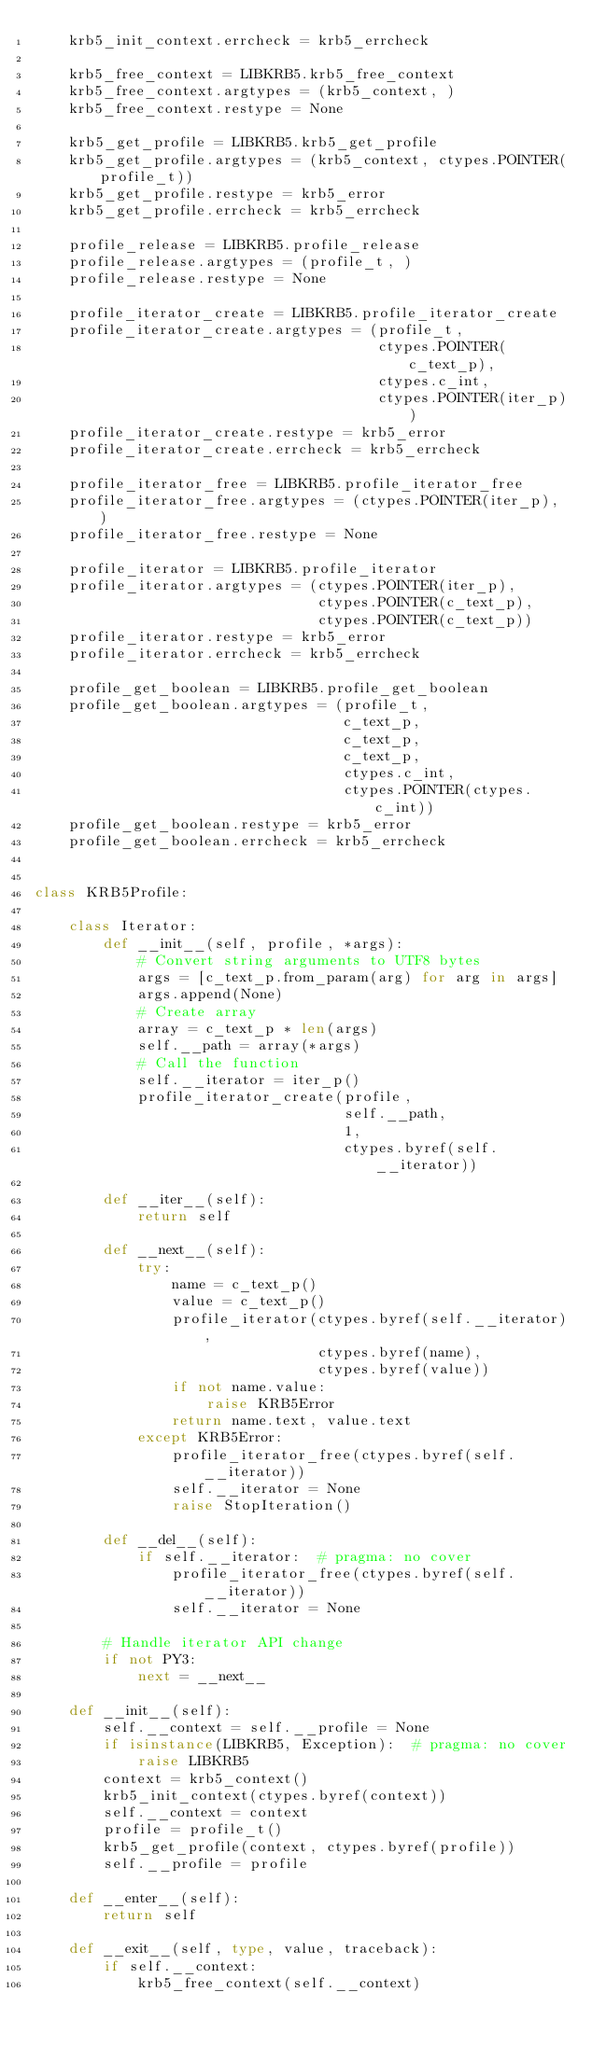Convert code to text. <code><loc_0><loc_0><loc_500><loc_500><_Python_>    krb5_init_context.errcheck = krb5_errcheck

    krb5_free_context = LIBKRB5.krb5_free_context
    krb5_free_context.argtypes = (krb5_context, )
    krb5_free_context.restype = None

    krb5_get_profile = LIBKRB5.krb5_get_profile
    krb5_get_profile.argtypes = (krb5_context, ctypes.POINTER(profile_t))
    krb5_get_profile.restype = krb5_error
    krb5_get_profile.errcheck = krb5_errcheck

    profile_release = LIBKRB5.profile_release
    profile_release.argtypes = (profile_t, )
    profile_release.restype = None

    profile_iterator_create = LIBKRB5.profile_iterator_create
    profile_iterator_create.argtypes = (profile_t,
                                        ctypes.POINTER(c_text_p),
                                        ctypes.c_int,
                                        ctypes.POINTER(iter_p))
    profile_iterator_create.restype = krb5_error
    profile_iterator_create.errcheck = krb5_errcheck

    profile_iterator_free = LIBKRB5.profile_iterator_free
    profile_iterator_free.argtypes = (ctypes.POINTER(iter_p), )
    profile_iterator_free.restype = None

    profile_iterator = LIBKRB5.profile_iterator
    profile_iterator.argtypes = (ctypes.POINTER(iter_p),
                                 ctypes.POINTER(c_text_p),
                                 ctypes.POINTER(c_text_p))
    profile_iterator.restype = krb5_error
    profile_iterator.errcheck = krb5_errcheck

    profile_get_boolean = LIBKRB5.profile_get_boolean
    profile_get_boolean.argtypes = (profile_t,
                                    c_text_p,
                                    c_text_p,
                                    c_text_p,
                                    ctypes.c_int,
                                    ctypes.POINTER(ctypes.c_int))
    profile_get_boolean.restype = krb5_error
    profile_get_boolean.errcheck = krb5_errcheck


class KRB5Profile:

    class Iterator:
        def __init__(self, profile, *args):
            # Convert string arguments to UTF8 bytes
            args = [c_text_p.from_param(arg) for arg in args]
            args.append(None)
            # Create array
            array = c_text_p * len(args)
            self.__path = array(*args)
            # Call the function
            self.__iterator = iter_p()
            profile_iterator_create(profile,
                                    self.__path,
                                    1,
                                    ctypes.byref(self.__iterator))

        def __iter__(self):
            return self

        def __next__(self):
            try:
                name = c_text_p()
                value = c_text_p()
                profile_iterator(ctypes.byref(self.__iterator),
                                 ctypes.byref(name),
                                 ctypes.byref(value))
                if not name.value:
                    raise KRB5Error
                return name.text, value.text
            except KRB5Error:
                profile_iterator_free(ctypes.byref(self.__iterator))
                self.__iterator = None
                raise StopIteration()

        def __del__(self):
            if self.__iterator:  # pragma: no cover
                profile_iterator_free(ctypes.byref(self.__iterator))
                self.__iterator = None

        # Handle iterator API change
        if not PY3:
            next = __next__

    def __init__(self):
        self.__context = self.__profile = None
        if isinstance(LIBKRB5, Exception):  # pragma: no cover
            raise LIBKRB5
        context = krb5_context()
        krb5_init_context(ctypes.byref(context))
        self.__context = context
        profile = profile_t()
        krb5_get_profile(context, ctypes.byref(profile))
        self.__profile = profile

    def __enter__(self):
        return self

    def __exit__(self, type, value, traceback):
        if self.__context:
            krb5_free_context(self.__context)</code> 